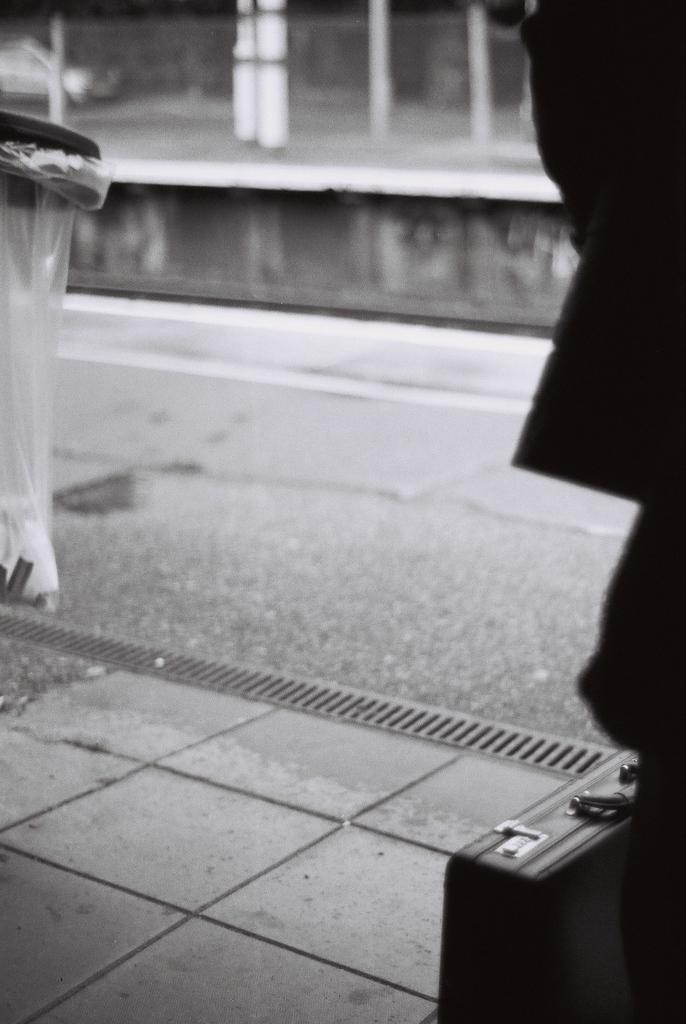What type of surface is shown in the image? The image depicts a sidewalk. What object is placed on the sidewalk? A suitcase is placed on the sidewalk. What feature is located near the sidewalk? There is a drainage grill near the sidewalk. What additional item can be seen in the image? A plastic bag is present in the image. What can be seen beyond the sidewalk in the image? There is a road visible in the image. What structure is visible in the image? There is a wall in the image. What type of prison is visible in the image? There is no prison present in the image. What type of berry can be seen growing on the wall in the image? There are no berries visible in the image; only a wall is present. 